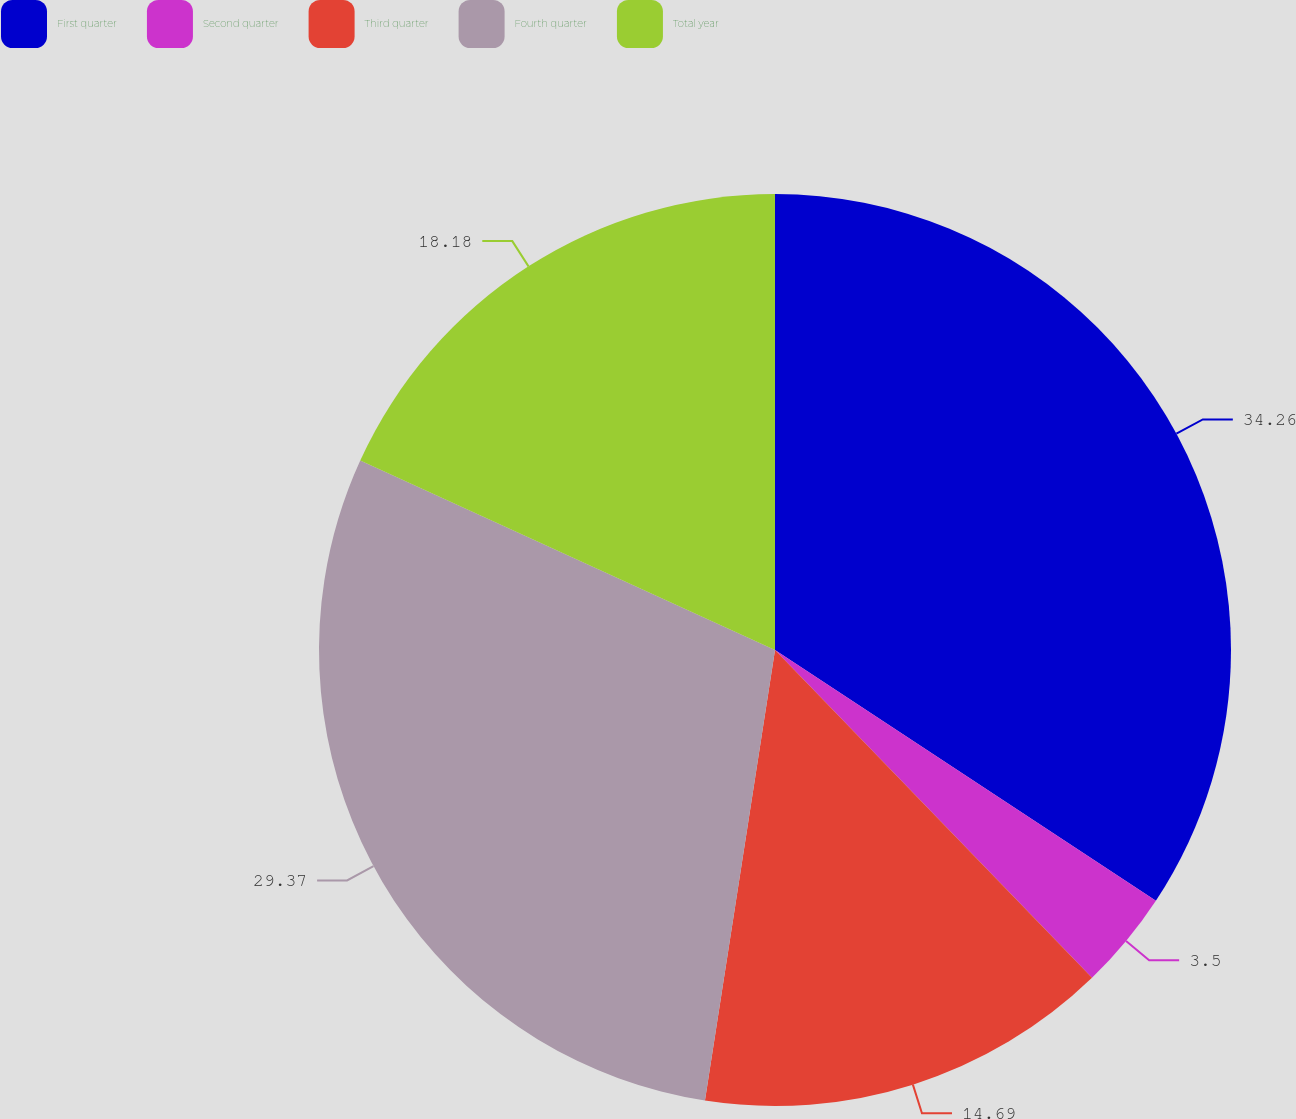Convert chart. <chart><loc_0><loc_0><loc_500><loc_500><pie_chart><fcel>First quarter<fcel>Second quarter<fcel>Third quarter<fcel>Fourth quarter<fcel>Total year<nl><fcel>34.27%<fcel>3.5%<fcel>14.69%<fcel>29.37%<fcel>18.18%<nl></chart> 